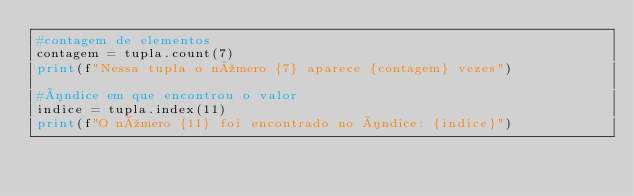<code> <loc_0><loc_0><loc_500><loc_500><_Python_>#contagem de elementos
contagem = tupla.count(7)
print(f"Nessa tupla o número {7} aparece {contagem} vezes")

#índice em que encontrou o valor
indice = tupla.index(11)
print(f"O número {11} foi encontrado no índice: {indice}")</code> 